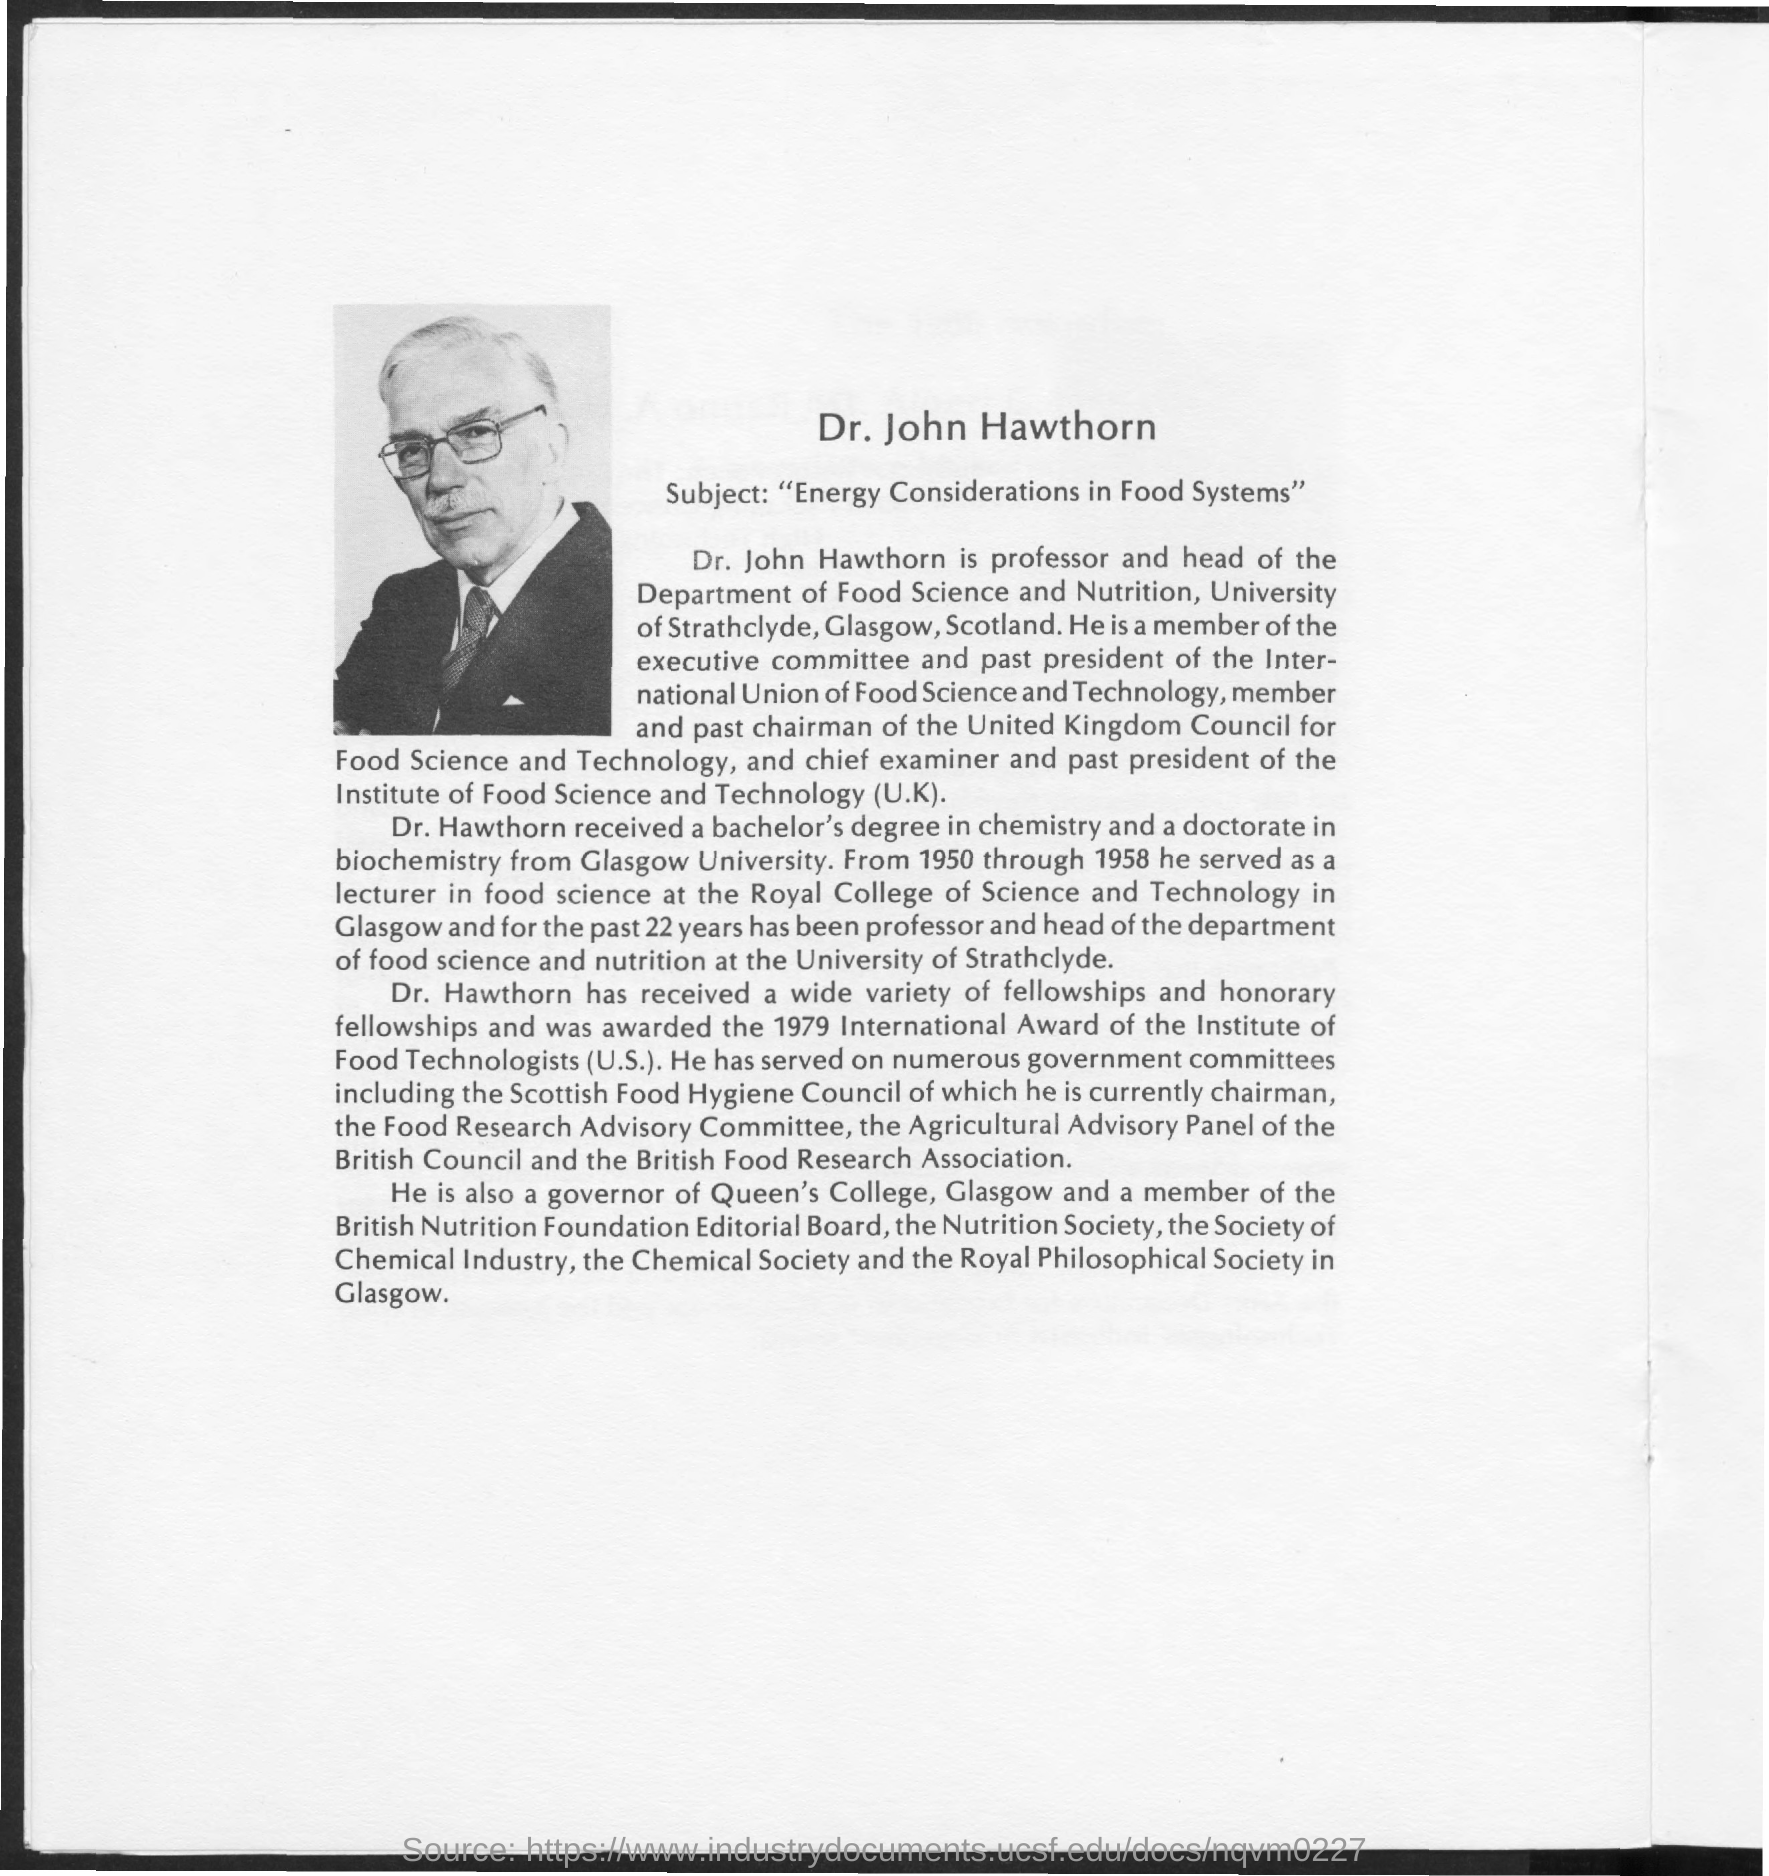Specify some key components in this picture. The subject of Dr. John is energy considerations in food systems. Dr. Hawthorn is currently the chairman of the Scottish Food Hygiene Council. The write-up mentions Dr. Hawthorn. Dr. Hawthorn received her bachelor's and doctorate degrees from Glasgow University. 